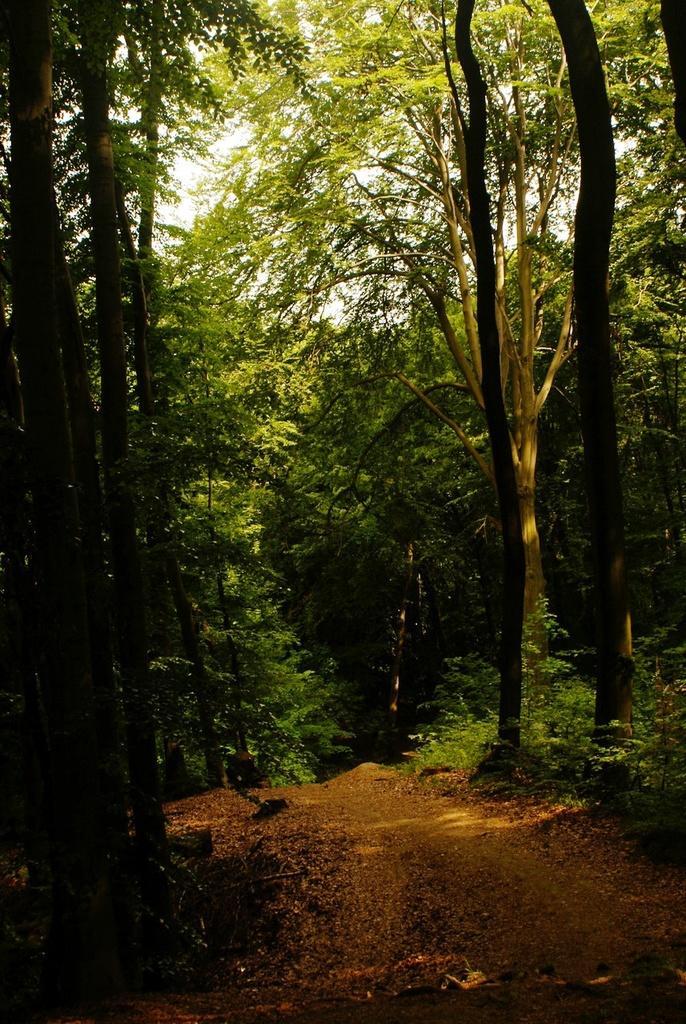In one or two sentences, can you explain what this image depicts? In this image there is a road with dried leaves. In the background of the image there are plants, trees and sky. 